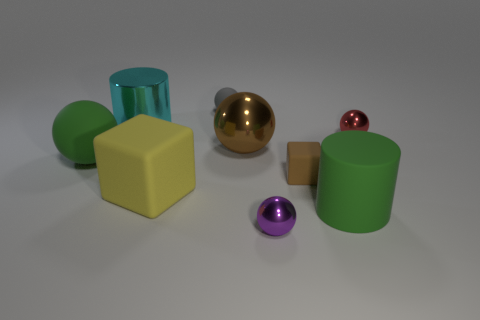Does the large cylinder in front of the tiny brown block have the same color as the large matte ball? Indeed, the large cylinder positioned in front of the diminutive brown block shares the same green hue as the large matte ball situated on the right. 